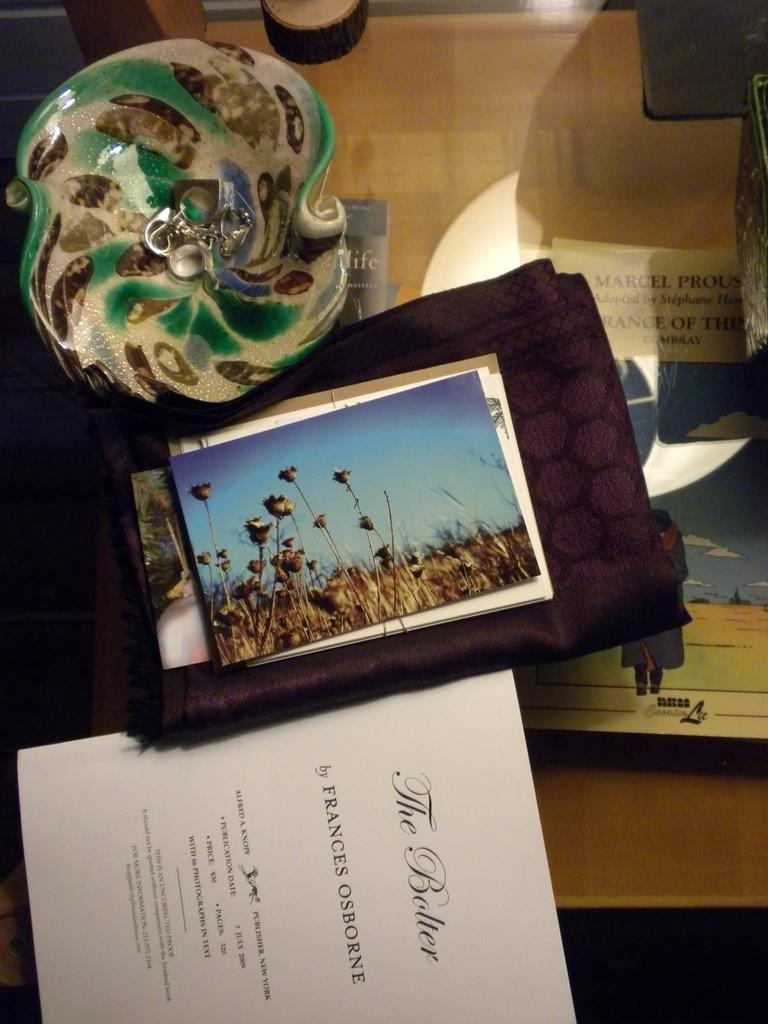What type of objects can be seen on the table in the image? There are colorful-glass objects and pictures on the table in the image. What is the color of the cloth in the image? The cloth in the image is brown. What is the table made of in the image? The table in the image is made of glass. What else is present in the image besides the table and cloth? There are papers and colorful-glass objects in the image. What type of glue is used to attach the caption to the picture in the image? There is no caption present in the image, so it is not possible to determine what type of glue might be used. What arithmetic problem is being solved on the papers in the image? There is no arithmetic problem visible on the papers in the image. 